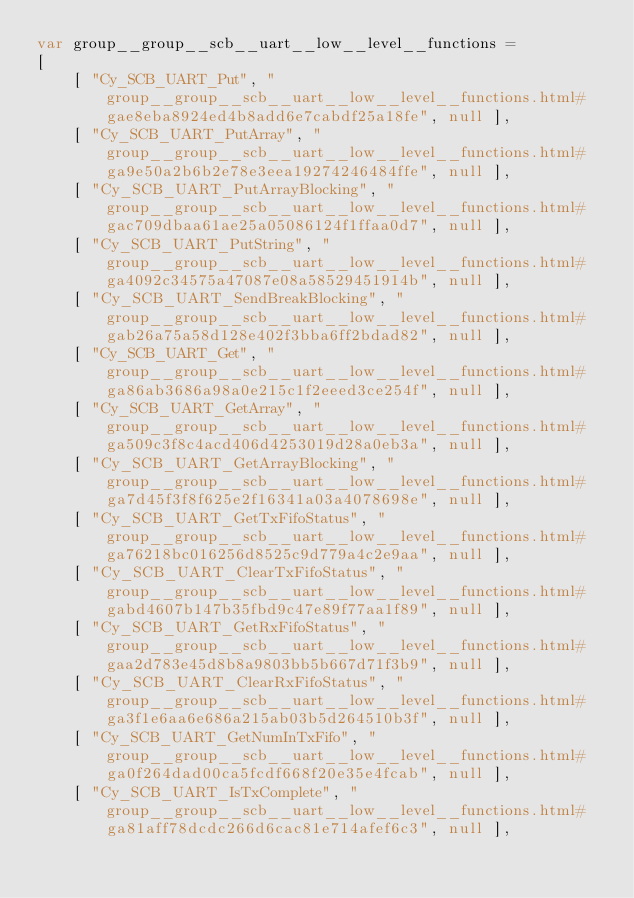<code> <loc_0><loc_0><loc_500><loc_500><_JavaScript_>var group__group__scb__uart__low__level__functions =
[
    [ "Cy_SCB_UART_Put", "group__group__scb__uart__low__level__functions.html#gae8eba8924ed4b8add6e7cabdf25a18fe", null ],
    [ "Cy_SCB_UART_PutArray", "group__group__scb__uart__low__level__functions.html#ga9e50a2b6b2e78e3eea19274246484ffe", null ],
    [ "Cy_SCB_UART_PutArrayBlocking", "group__group__scb__uart__low__level__functions.html#gac709dbaa61ae25a05086124f1ffaa0d7", null ],
    [ "Cy_SCB_UART_PutString", "group__group__scb__uart__low__level__functions.html#ga4092c34575a47087e08a58529451914b", null ],
    [ "Cy_SCB_UART_SendBreakBlocking", "group__group__scb__uart__low__level__functions.html#gab26a75a58d128e402f3bba6ff2bdad82", null ],
    [ "Cy_SCB_UART_Get", "group__group__scb__uart__low__level__functions.html#ga86ab3686a98a0e215c1f2eeed3ce254f", null ],
    [ "Cy_SCB_UART_GetArray", "group__group__scb__uart__low__level__functions.html#ga509c3f8c4acd406d4253019d28a0eb3a", null ],
    [ "Cy_SCB_UART_GetArrayBlocking", "group__group__scb__uart__low__level__functions.html#ga7d45f3f8f625e2f16341a03a4078698e", null ],
    [ "Cy_SCB_UART_GetTxFifoStatus", "group__group__scb__uart__low__level__functions.html#ga76218bc016256d8525c9d779a4c2e9aa", null ],
    [ "Cy_SCB_UART_ClearTxFifoStatus", "group__group__scb__uart__low__level__functions.html#gabd4607b147b35fbd9c47e89f77aa1f89", null ],
    [ "Cy_SCB_UART_GetRxFifoStatus", "group__group__scb__uart__low__level__functions.html#gaa2d783e45d8b8a9803bb5b667d71f3b9", null ],
    [ "Cy_SCB_UART_ClearRxFifoStatus", "group__group__scb__uart__low__level__functions.html#ga3f1e6aa6e686a215ab03b5d264510b3f", null ],
    [ "Cy_SCB_UART_GetNumInTxFifo", "group__group__scb__uart__low__level__functions.html#ga0f264dad00ca5fcdf668f20e35e4fcab", null ],
    [ "Cy_SCB_UART_IsTxComplete", "group__group__scb__uart__low__level__functions.html#ga81aff78dcdc266d6cac81e714afef6c3", null ],</code> 